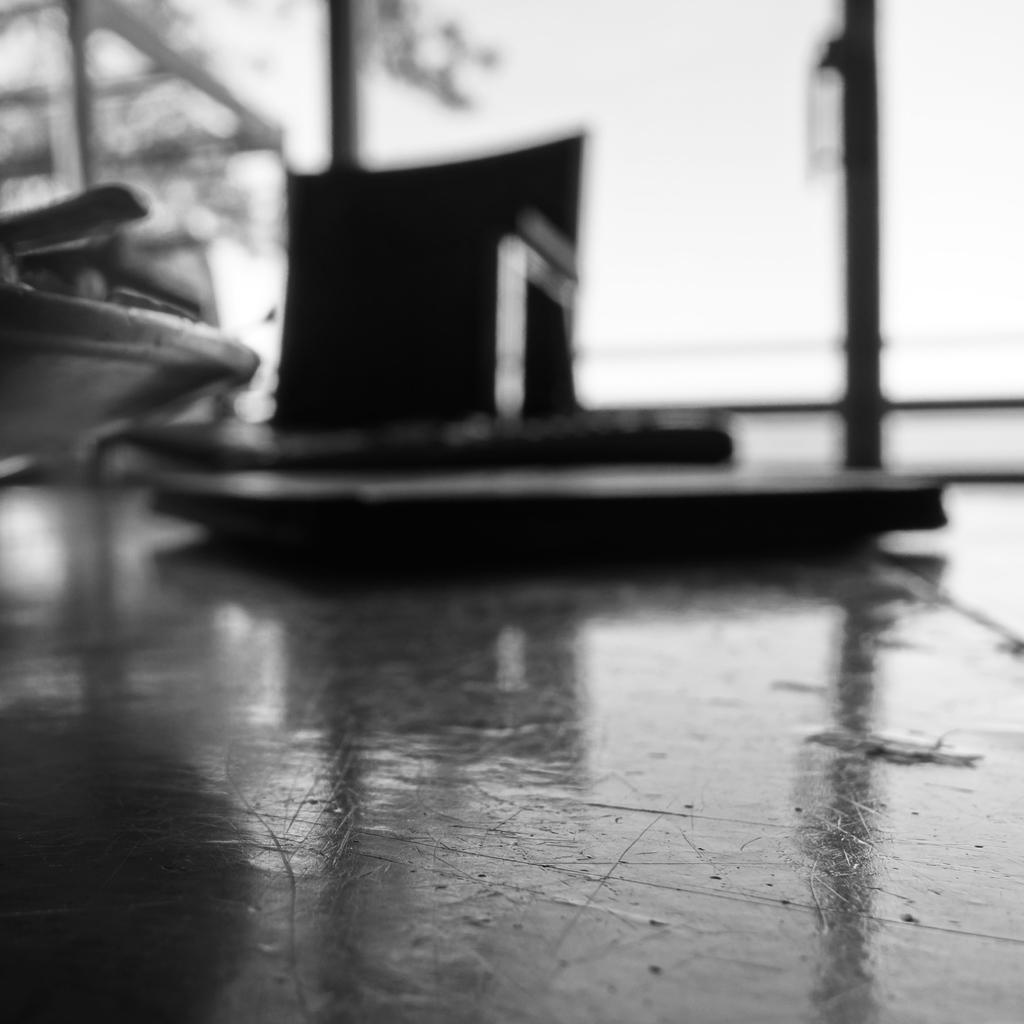What can be seen on the floor in the image? There are objects on the floor in the image. What is visible in the background of the image? There is a window visible in the background of the image. Where might this image have been taken? The image is likely taken in a room, given the presence of a window in the background. What type of notebook is being used to promote peace in the image? There is no notebook or reference to peace present in the image. 